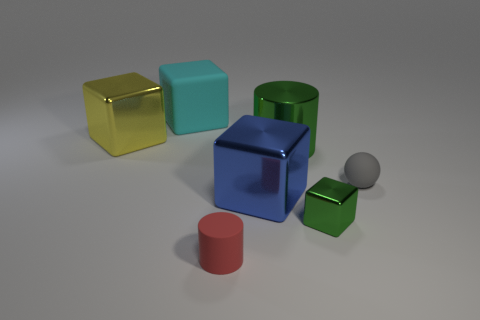What number of things are either small cyan metallic blocks or cubes that are to the right of the red rubber thing?
Offer a terse response. 2. Are the large green object right of the tiny rubber cylinder and the big object on the left side of the cyan rubber cube made of the same material?
Your answer should be very brief. Yes. There is a small thing that is the same color as the big metallic cylinder; what is its shape?
Ensure brevity in your answer.  Cube. How many gray things are large shiny balls or tiny matte cylinders?
Make the answer very short. 0. How big is the green metallic cube?
Your answer should be compact. Small. Is the number of gray spheres on the left side of the large yellow metallic block greater than the number of small metallic cubes?
Your response must be concise. No. How many metal things are to the right of the large blue metallic cube?
Keep it short and to the point. 2. Are there any rubber cylinders of the same size as the ball?
Give a very brief answer. Yes. The tiny metallic object that is the same shape as the large matte object is what color?
Provide a succinct answer. Green. Is the size of the block on the left side of the large rubber block the same as the block that is to the right of the big blue shiny cube?
Your response must be concise. No. 